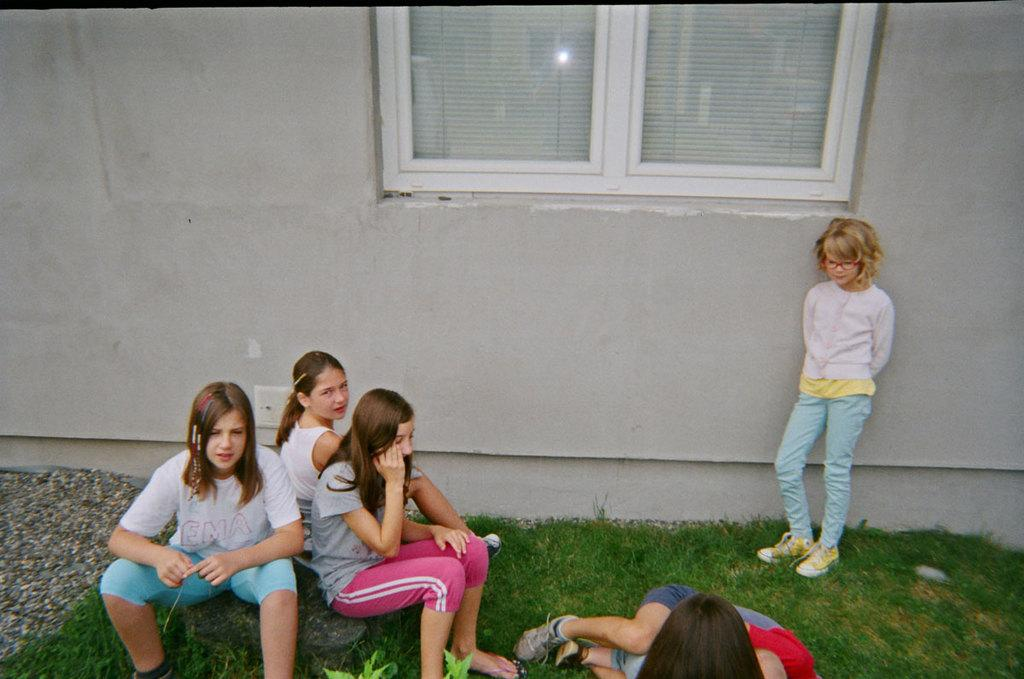How many girls are sitting on the left side of the image? There are three girls sitting on the left side of the image. What is the girl on the right side of the image doing? The girl on the right side of the image is standing. What color is the sweater worn by the standing girl? The girl standing is wearing a white color sweater. What can be seen on the wall in the middle of the image? There is a window on the wall in the middle of the image. What type of coal can be seen in the image? There is no coal present in the image. 